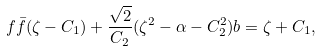Convert formula to latex. <formula><loc_0><loc_0><loc_500><loc_500>f \bar { f } ( \zeta - C _ { 1 } ) + \frac { \sqrt { 2 } } { C _ { 2 } } ( \zeta ^ { 2 } - \alpha - C _ { 2 } ^ { 2 } ) b = \zeta + C _ { 1 } ,</formula> 